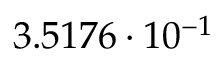<formula> <loc_0><loc_0><loc_500><loc_500>3 . 5 1 7 6 \cdot 1 0 ^ { - 1 }</formula> 